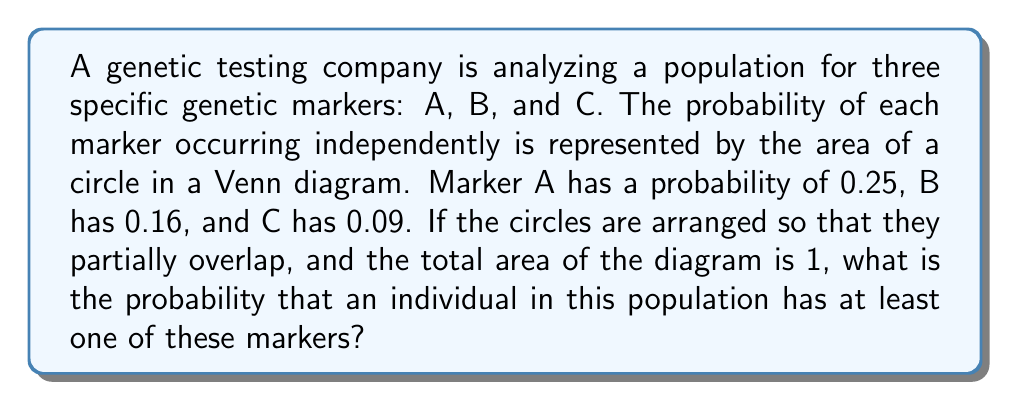Solve this math problem. Let's approach this step-by-step using geometric probability:

1) First, we need to calculate the radii of the circles:
   For A: $r_A = \sqrt{\frac{0.25}{\pi}} \approx 0.2821$
   For B: $r_B = \sqrt{\frac{0.16}{\pi}} \approx 0.2257$
   For C: $r_C = \sqrt{\frac{0.09}{\pi}} \approx 0.1690$

2) The total area of the Venn diagram is 1, which represents the entire population.

3) The probability of having at least one marker is equal to 1 minus the probability of having none of the markers.

4) The area where none of the markers are present is represented by the area outside all three circles.

5) Therefore, the probability we're looking for is:

   $$P(\text{at least one marker}) = 1 - P(\text{no markers})$$

6) To calculate $P(\text{no markers})$, we need to subtract the total area of the circles from 1, accounting for any overlaps to avoid double-counting:

   $$P(\text{no markers}) = 1 - (A_A + A_B + A_C - A_{AB} - A_{BC} - A_{AC} + A_{ABC})$$

   Where $A_X$ represents the area of circle X, and $A_{XY}$ represents the area of overlap between circles X and Y.

7) We know $A_A = 0.25$, $A_B = 0.16$, and $A_C = 0.09$. The overlapping areas can be calculated using the formula for the area of intersection of two circles:

   $$A_{XY} = 2r_X^2 \arccos(\frac{d^2 + r_X^2 - r_Y^2}{2dr_X}) + 2r_Y^2 \arccos(\frac{d^2 + r_Y^2 - r_X^2}{2dr_Y}) - d\sqrt{(-d+r_X+r_Y)(d+r_X-r_Y)(d-r_X+r_Y)(d+r_X+r_Y)}$$

   Where $d$ is the distance between the centers of the circles.

8) For simplicity, let's assume the circles are arranged so that each pair of circles intersects with an overlap area of 0.03. This gives us:

   $A_{AB} = A_{BC} = A_{AC} = 0.03$

9) The area where all three circles overlap ($A_{ABC}$) would be smaller, let's assume it's 0.01.

10) Plugging these values into our equation:

    $$P(\text{no markers}) = 1 - (0.25 + 0.16 + 0.09 - 0.03 - 0.03 - 0.03 + 0.01) = 0.58$$

11) Therefore, the probability of having at least one marker is:

    $$P(\text{at least one marker}) = 1 - 0.58 = 0.42$$
Answer: 0.42 